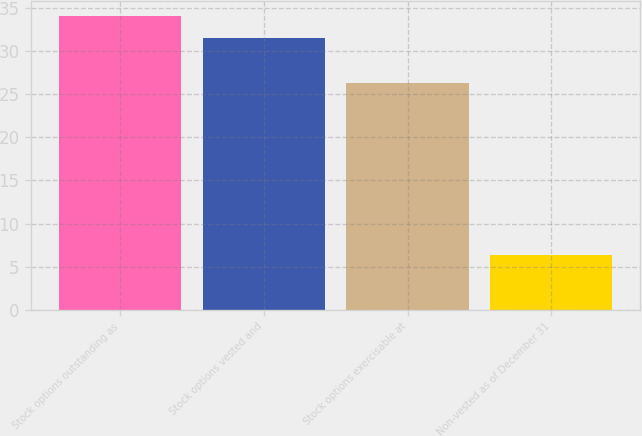Convert chart. <chart><loc_0><loc_0><loc_500><loc_500><bar_chart><fcel>Stock options outstanding as<fcel>Stock options vested and<fcel>Stock options exercisable at<fcel>Non-vested as of December 31<nl><fcel>34.13<fcel>31.5<fcel>26.3<fcel>6.3<nl></chart> 